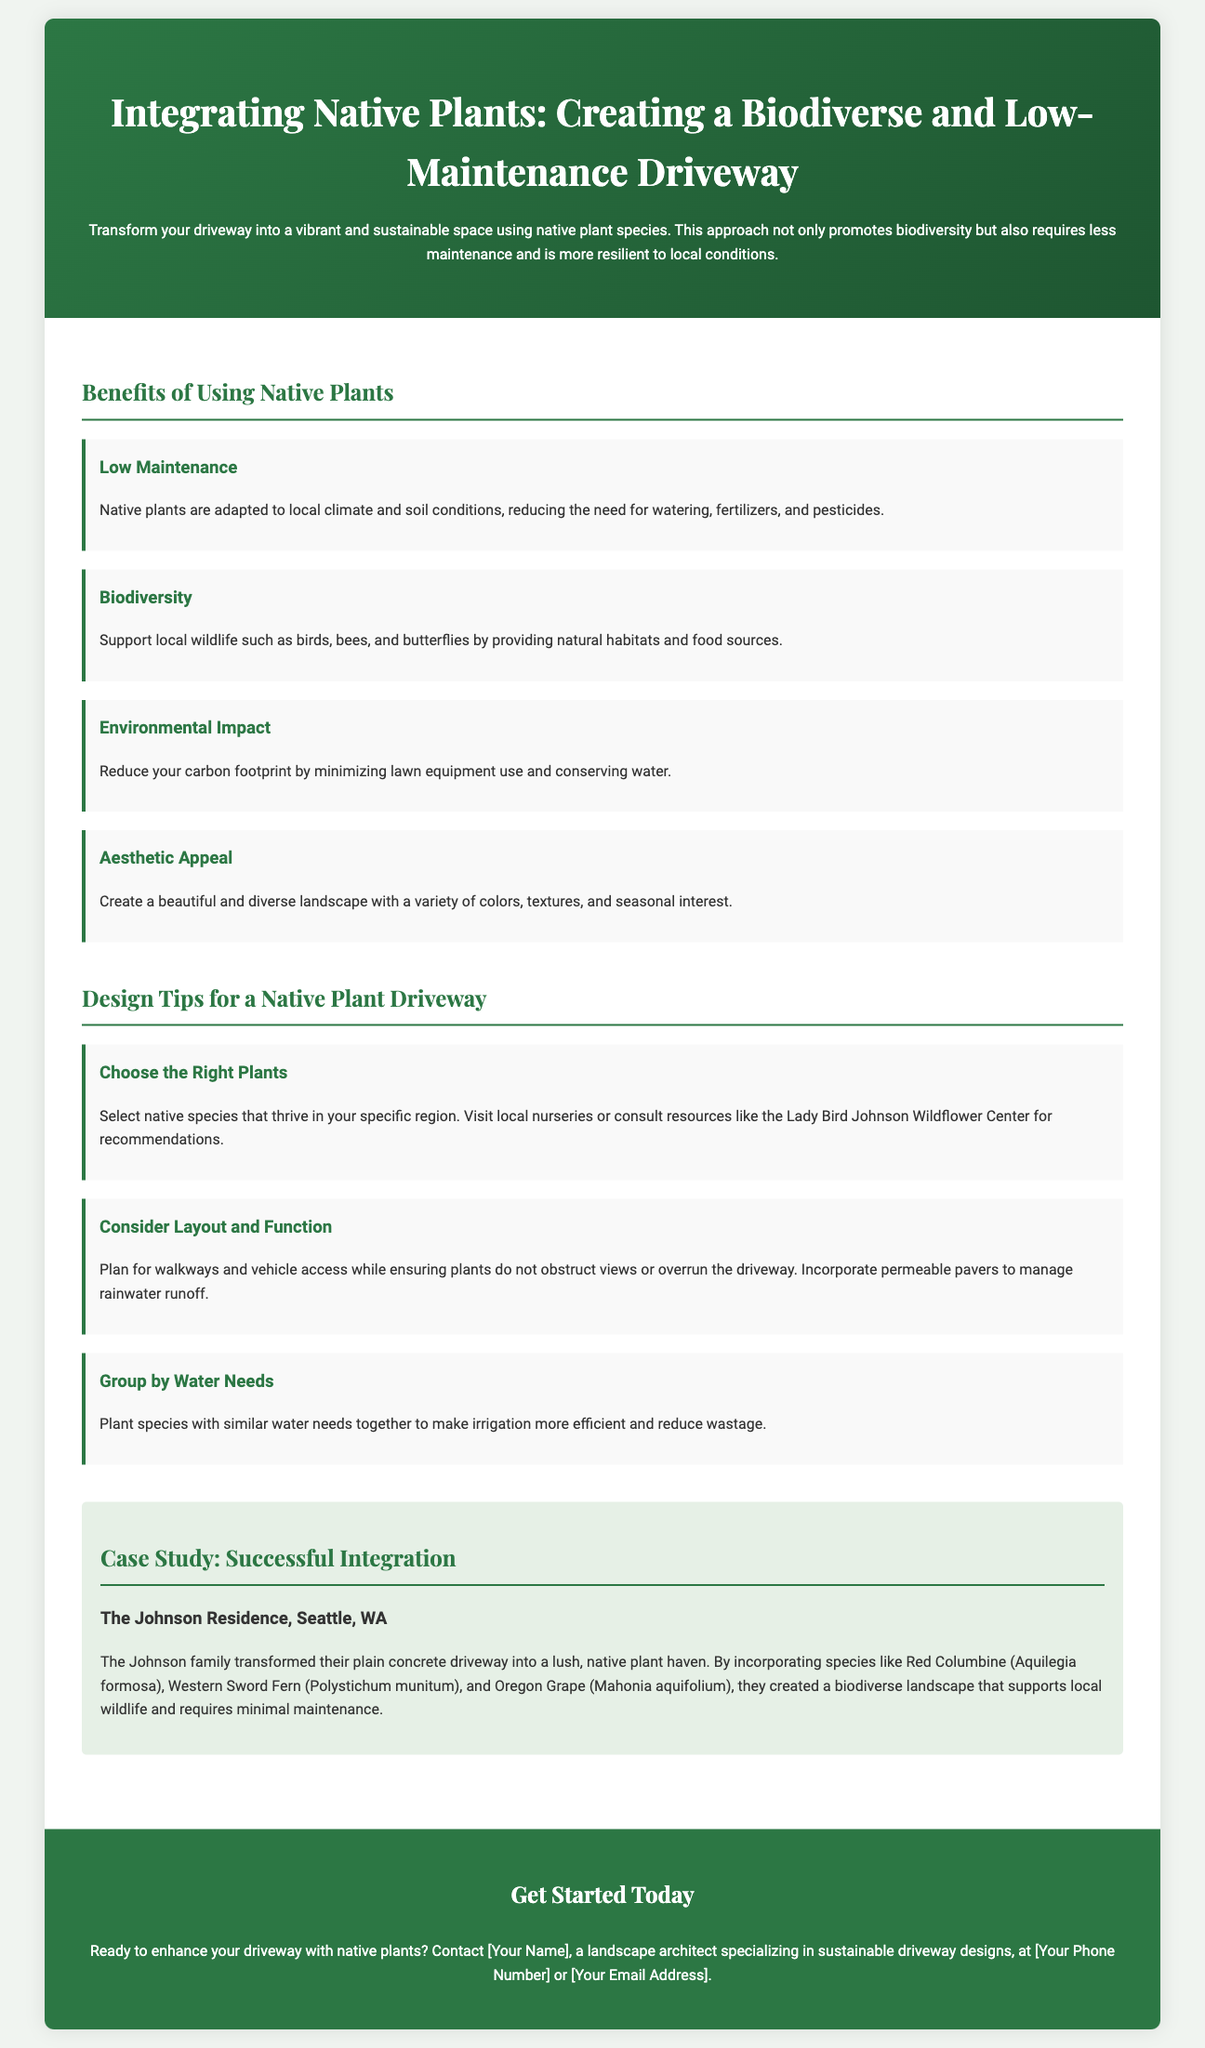what is the title of the flyer? The title of the flyer is stated in the header section, which introduces the primary topic of the document.
Answer: Integrating Native Plants: Creating a Biodiverse and Low-Maintenance Driveway what are two benefits of using native plants? The flyer lists several benefits in the benefits section, providing specific details about the advantages of native plants.
Answer: Low Maintenance, Biodiversity which case study is featured in the document? The case study section identifies a specific residence that exemplifies the successful integration of native plants.
Answer: The Johnson Residence, Seattle, WA how many design tips are provided in the flyer? The design tips section outlines specific strategies for creating a native plant driveway, which can be counted directly.
Answer: Three what is one native plant mentioned in the case study? The case study mentions specific native plants that were incorporated into the driveway at the Johnson residence.
Answer: Red Columbine who can you contact for more information? The contact information section states who to reach out to for further queries related to the flyer content.
Answer: [Your Name] 